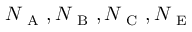Convert formula to latex. <formula><loc_0><loc_0><loc_500><loc_500>N _ { A } , N _ { B } , N _ { C } , N _ { E }</formula> 